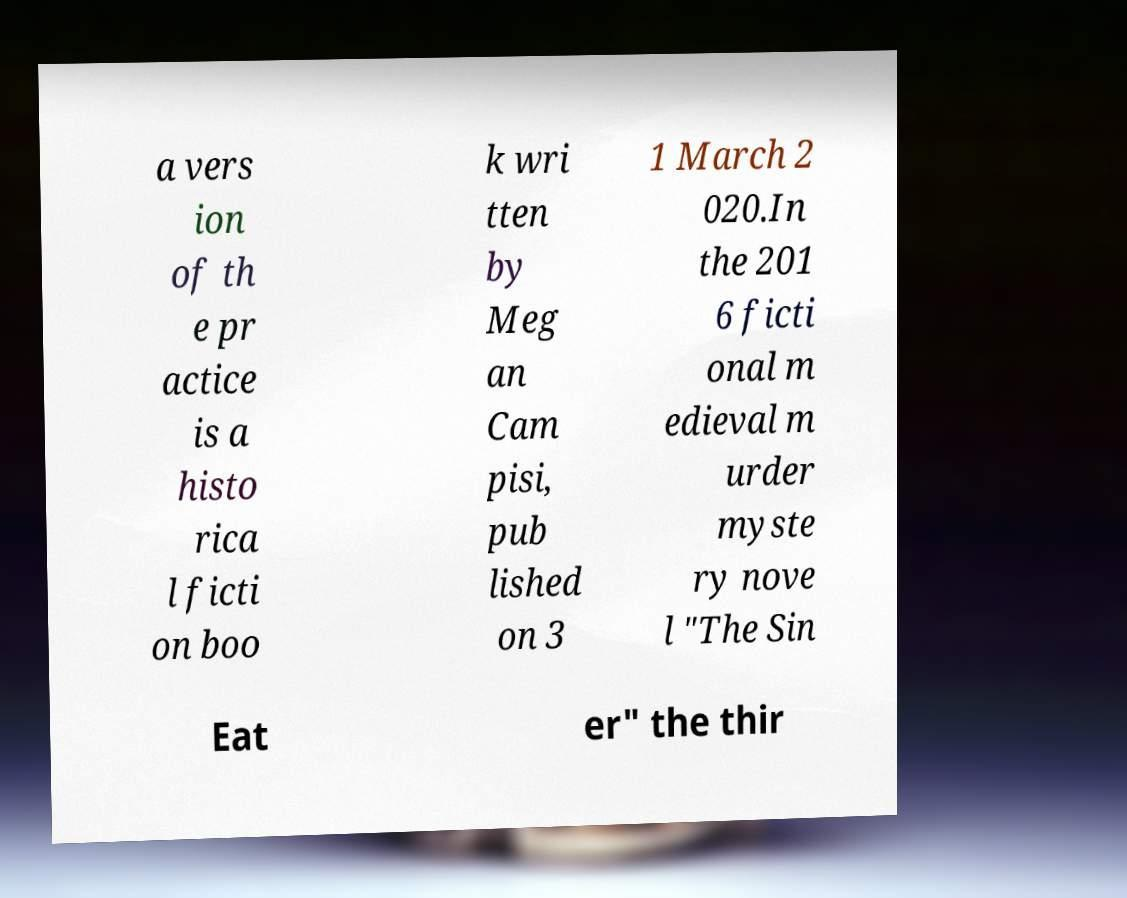There's text embedded in this image that I need extracted. Can you transcribe it verbatim? a vers ion of th e pr actice is a histo rica l ficti on boo k wri tten by Meg an Cam pisi, pub lished on 3 1 March 2 020.In the 201 6 ficti onal m edieval m urder myste ry nove l "The Sin Eat er" the thir 